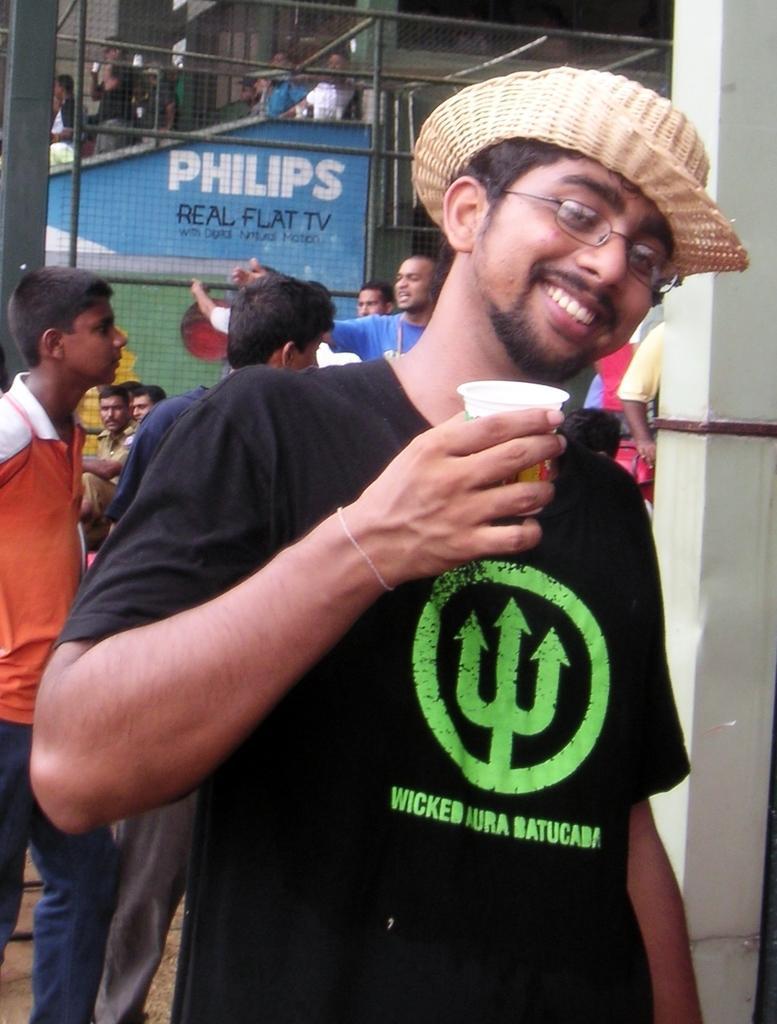Can you describe this image briefly? In this image we can see a man holding a cup with his hand and he is smiling. He wore spectacles and a hat. In the background we can see pillars, poles, mesh, board, and people. 